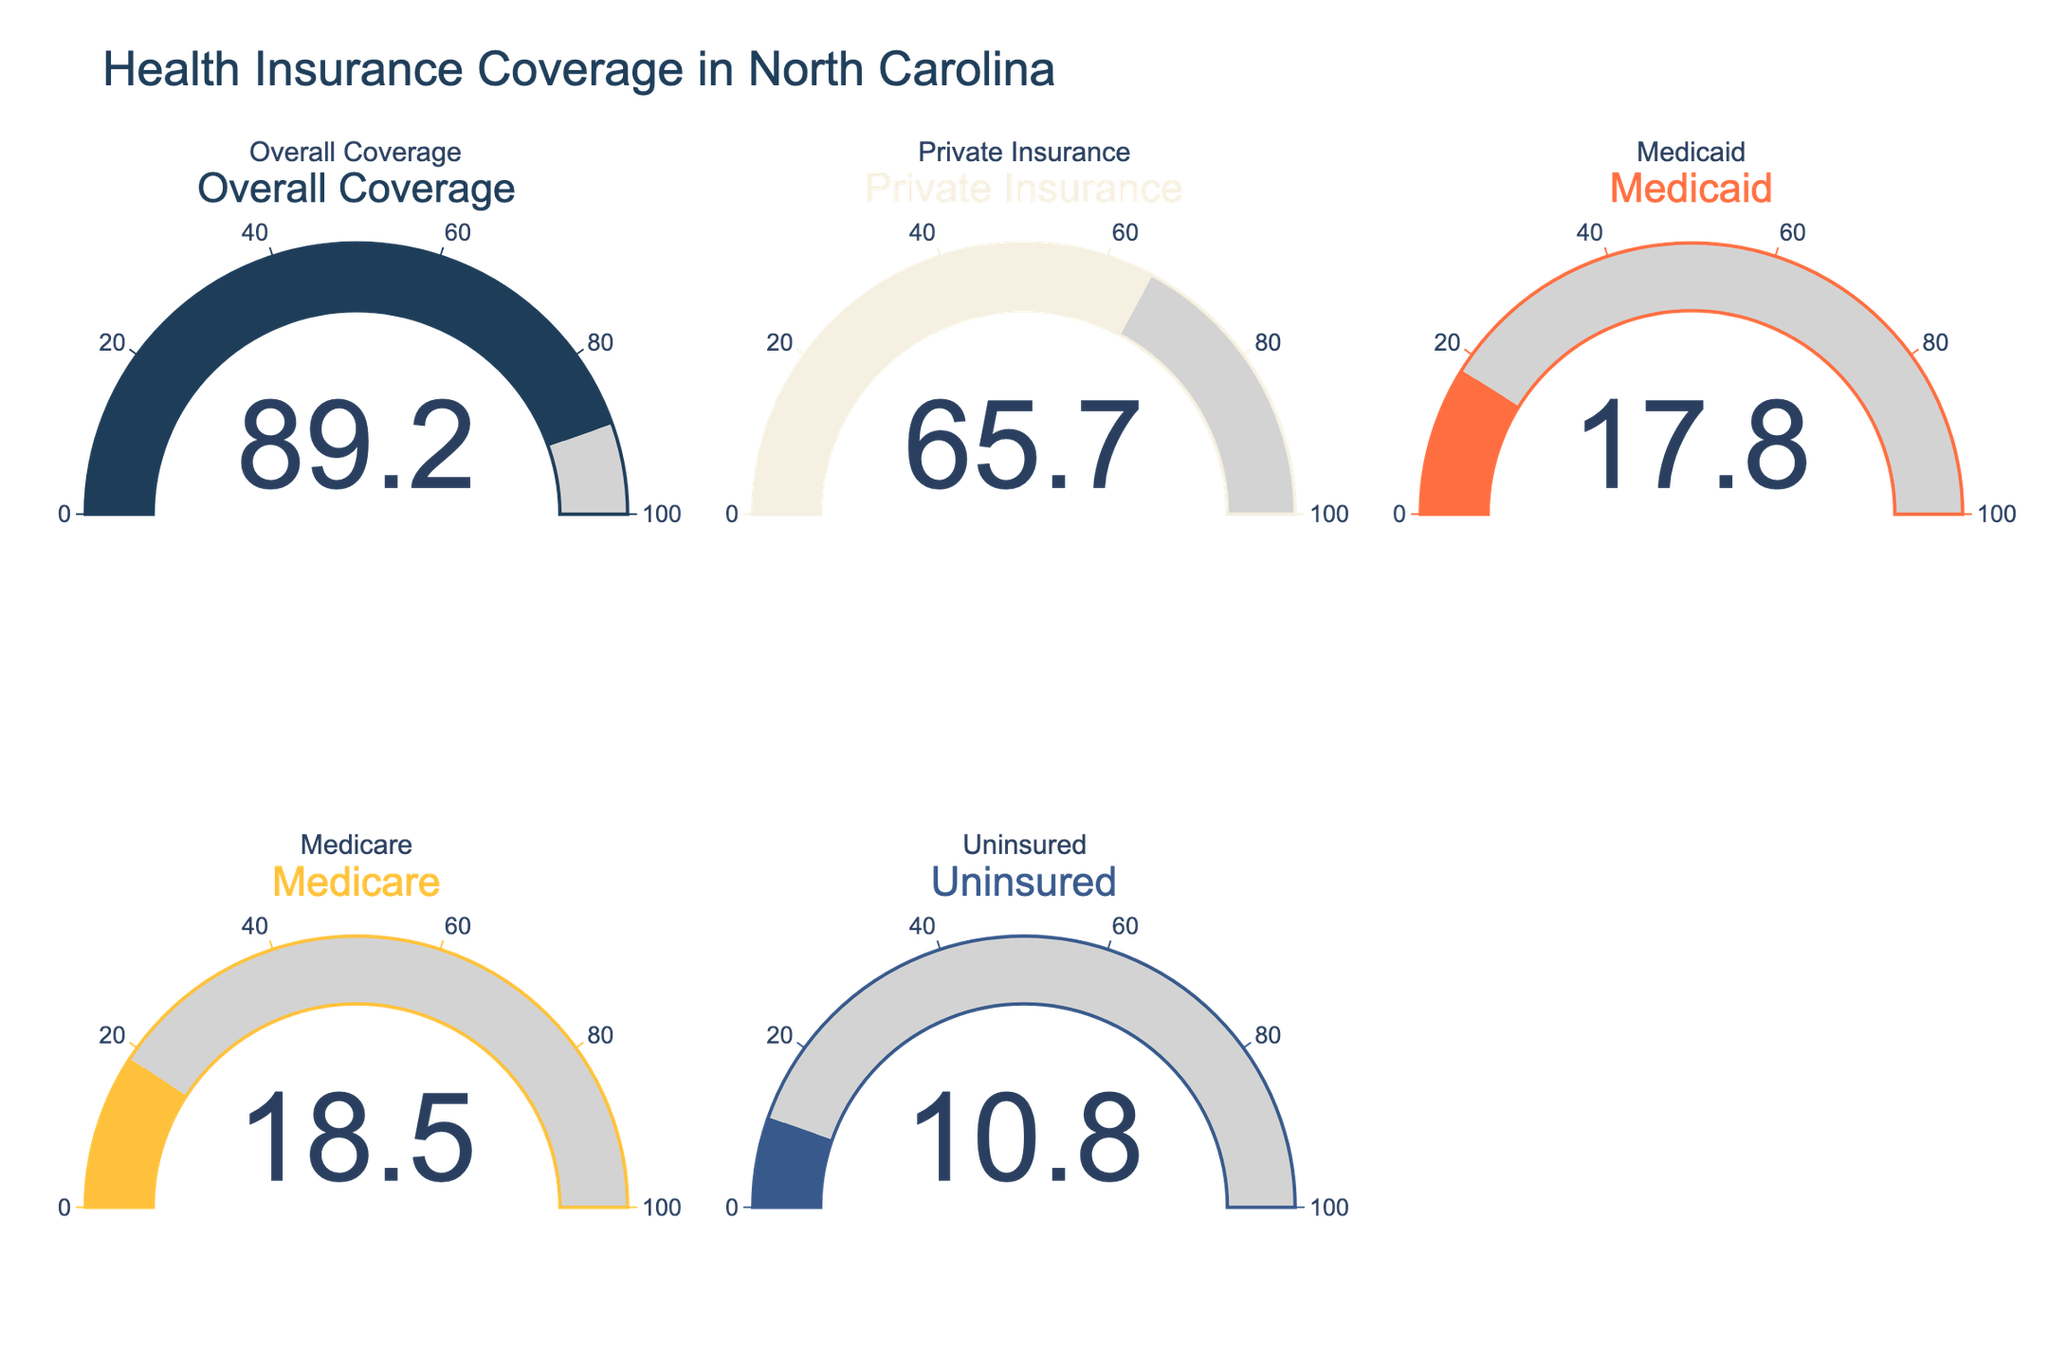What's the percentage of North Carolina residents with overall health insurance coverage? The gauge chart for "Overall Coverage" indicates the percentage of North Carolina residents with health insurance coverage. According to the figure, the gauge for "Overall Coverage" shows a value.
Answer: 89.2% What percentage of North Carolina residents are uninsured? The figure includes a gauge chart specifically for the "Uninsured" category, and it displays a percentage indicating the portion of residents without health insurance.
Answer: 10.8% Which type of insurance has the highest coverage among North Carolina residents? By comparing the values displayed on all the gauge charts, we see that "Private Insurance" has the highest percentage coverage among the types listed.
Answer: Private Insurance How much higher is the percentage of residents with private insurance compared to those with Medicaid? To find the difference, subtract the percentage of Medicaid coverage from the percentage of Private Insurance coverage: 65.7% - 17.8%.
Answer: 47.9% What's the sum of the percentages for Medicare and Medicaid coverage? Add the percentage for Medicare (18.5%) to the percentage for Medicaid (17.8%) to get the total percentage for these two categories.
Answer: 36.3% Which type of insurance has the lowest coverage after uninsured residents? By examining the gauge charts, we see that Medicaid has the lowest coverage percentage next to the uninsured category.
Answer: Medicaid Is the percentage of residents with overall coverage greater than those with private insurance? Compare the percentages shown in the gauge charts for "Overall Coverage" and "Private Insurance". "Overall Coverage" indicates 89.2%, while "Private Insurance" shows 65.7%. Thus, the overall coverage is greater.
Answer: Yes By how much does the percentage of uninsured residents fall short of 100%? Subtract the percentage of uninsured residents (10.8%) from 100% to find the shortfall.
Answer: 89.2% 